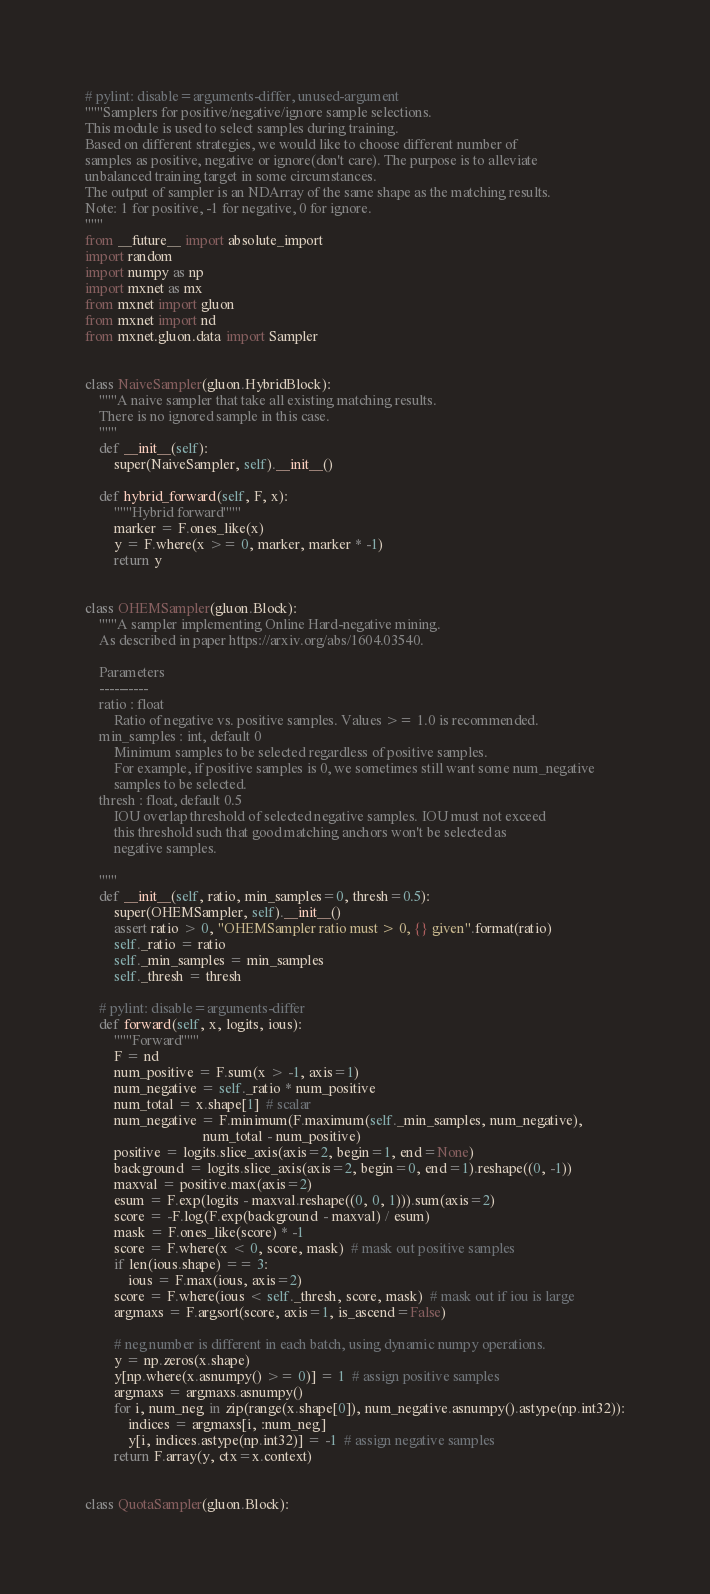<code> <loc_0><loc_0><loc_500><loc_500><_Python_># pylint: disable=arguments-differ, unused-argument
"""Samplers for positive/negative/ignore sample selections.
This module is used to select samples during training.
Based on different strategies, we would like to choose different number of
samples as positive, negative or ignore(don't care). The purpose is to alleviate
unbalanced training target in some circumstances.
The output of sampler is an NDArray of the same shape as the matching results.
Note: 1 for positive, -1 for negative, 0 for ignore.
"""
from __future__ import absolute_import
import random
import numpy as np
import mxnet as mx
from mxnet import gluon
from mxnet import nd
from mxnet.gluon.data import Sampler


class NaiveSampler(gluon.HybridBlock):
    """A naive sampler that take all existing matching results.
    There is no ignored sample in this case.
    """
    def __init__(self):
        super(NaiveSampler, self).__init__()

    def hybrid_forward(self, F, x):
        """Hybrid forward"""
        marker = F.ones_like(x)
        y = F.where(x >= 0, marker, marker * -1)
        return y


class OHEMSampler(gluon.Block):
    """A sampler implementing Online Hard-negative mining.
    As described in paper https://arxiv.org/abs/1604.03540.

    Parameters
    ----------
    ratio : float
        Ratio of negative vs. positive samples. Values >= 1.0 is recommended.
    min_samples : int, default 0
        Minimum samples to be selected regardless of positive samples.
        For example, if positive samples is 0, we sometimes still want some num_negative
        samples to be selected.
    thresh : float, default 0.5
        IOU overlap threshold of selected negative samples. IOU must not exceed
        this threshold such that good matching anchors won't be selected as
        negative samples.

    """
    def __init__(self, ratio, min_samples=0, thresh=0.5):
        super(OHEMSampler, self).__init__()
        assert ratio > 0, "OHEMSampler ratio must > 0, {} given".format(ratio)
        self._ratio = ratio
        self._min_samples = min_samples
        self._thresh = thresh

    # pylint: disable=arguments-differ
    def forward(self, x, logits, ious):
        """Forward"""
        F = nd
        num_positive = F.sum(x > -1, axis=1)
        num_negative = self._ratio * num_positive
        num_total = x.shape[1]  # scalar
        num_negative = F.minimum(F.maximum(self._min_samples, num_negative),
                                 num_total - num_positive)
        positive = logits.slice_axis(axis=2, begin=1, end=None)
        background = logits.slice_axis(axis=2, begin=0, end=1).reshape((0, -1))
        maxval = positive.max(axis=2)
        esum = F.exp(logits - maxval.reshape((0, 0, 1))).sum(axis=2)
        score = -F.log(F.exp(background - maxval) / esum)
        mask = F.ones_like(score) * -1
        score = F.where(x < 0, score, mask)  # mask out positive samples
        if len(ious.shape) == 3:
            ious = F.max(ious, axis=2)
        score = F.where(ious < self._thresh, score, mask)  # mask out if iou is large
        argmaxs = F.argsort(score, axis=1, is_ascend=False)

        # neg number is different in each batch, using dynamic numpy operations.
        y = np.zeros(x.shape)
        y[np.where(x.asnumpy() >= 0)] = 1  # assign positive samples
        argmaxs = argmaxs.asnumpy()
        for i, num_neg in zip(range(x.shape[0]), num_negative.asnumpy().astype(np.int32)):
            indices = argmaxs[i, :num_neg]
            y[i, indices.astype(np.int32)] = -1  # assign negative samples
        return F.array(y, ctx=x.context)


class QuotaSampler(gluon.Block):</code> 